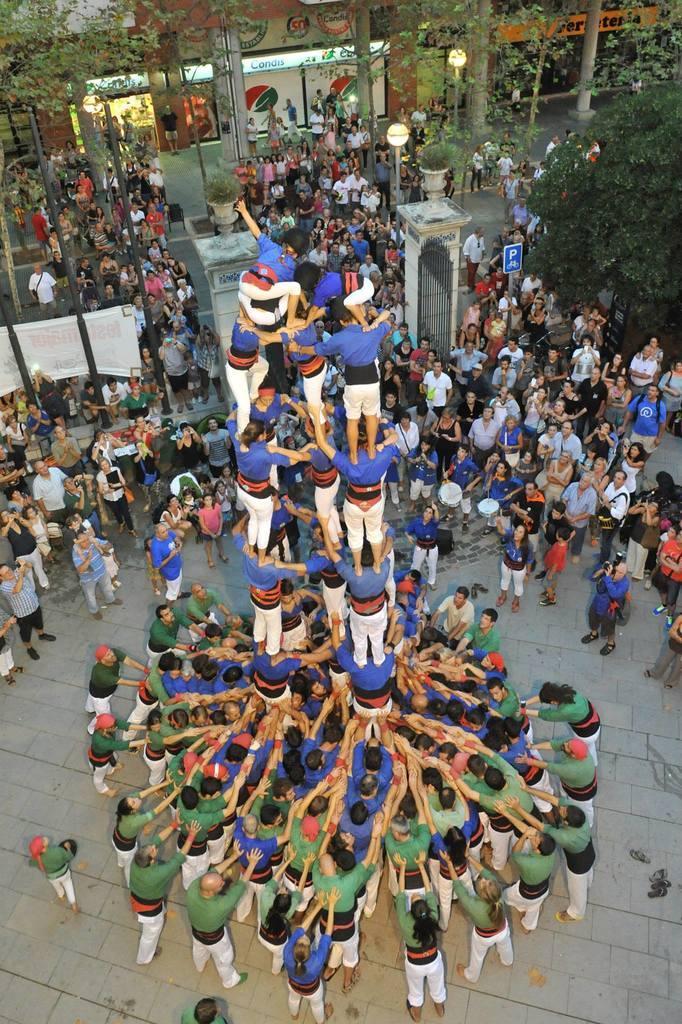How would you summarize this image in a sentence or two? In this picture, we can see a few people on the ground, among them a few are holding objects, a few are performing a pyramid, and we can see the ground, gate, fencing, and some objects on it, we can see plants in pot, trees, stores, poles, posters, and some lights. 